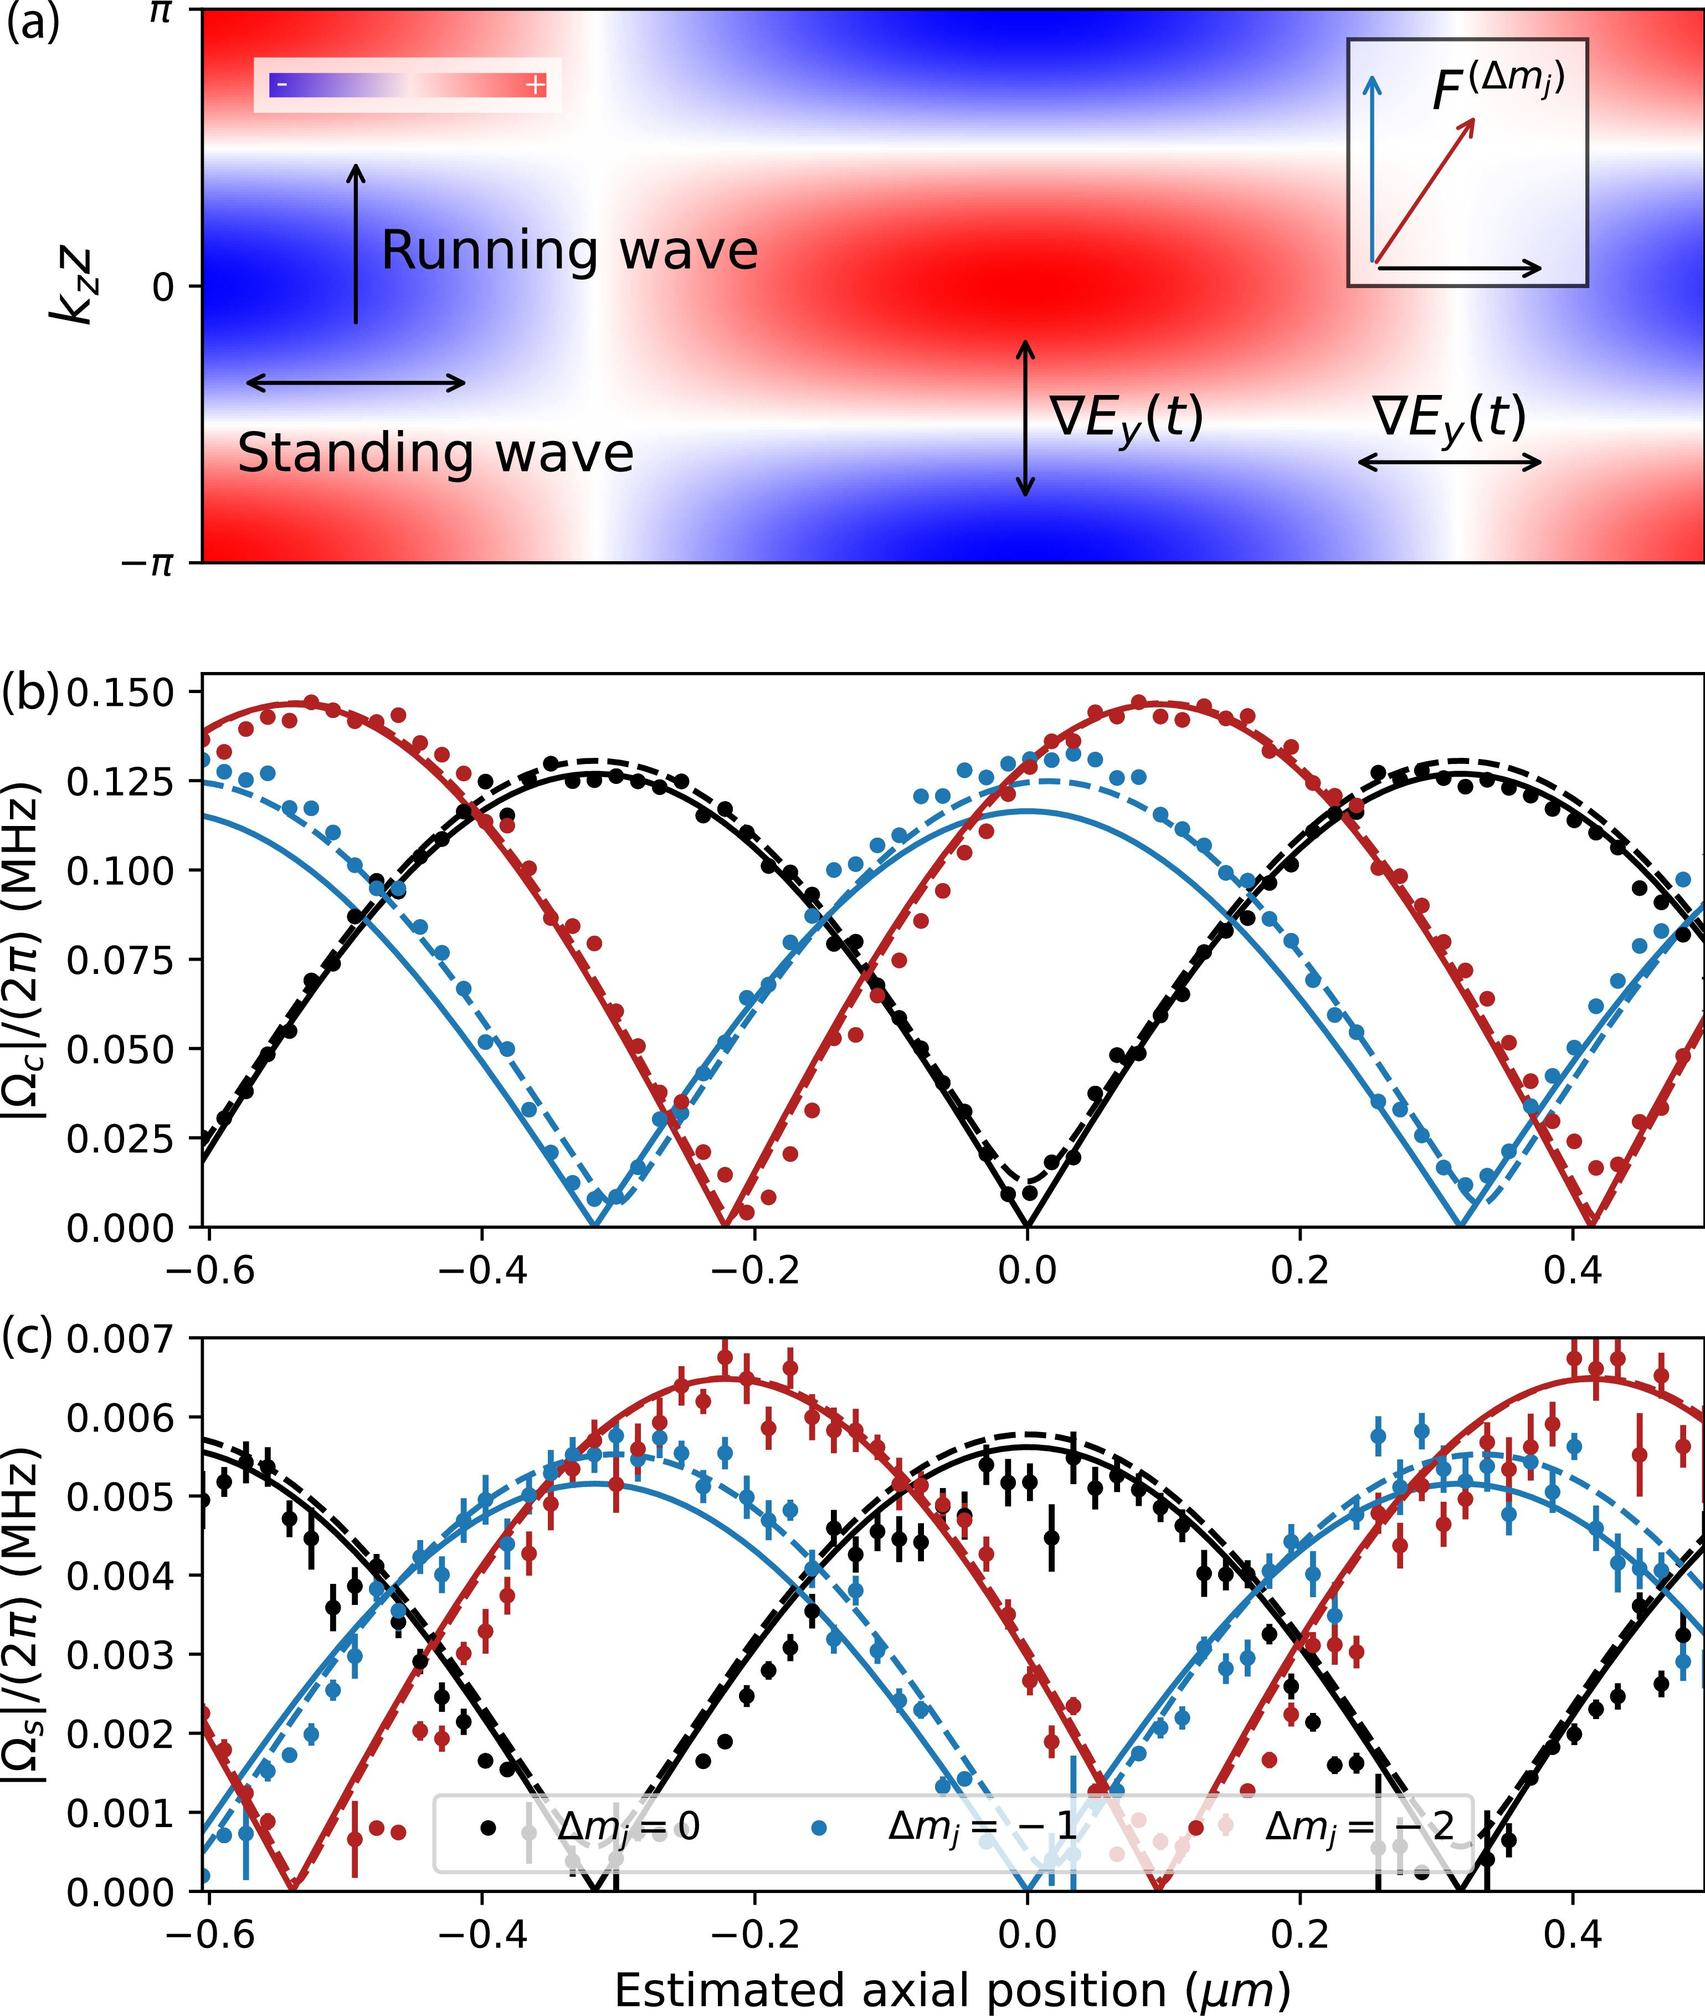Based on Figure (c), which \( \Delta m_j \) value corresponds to the largest variation in \( \Omega_S \) with respect to the estimated axial position? A. \( \Delta m_j = 0 \) B. \( \Delta m_j = -1 \) C. \( \Delta m_j = +2 \) D. \( \Delta m_j = +1 \) In Figure (c), the red curve represents \( \Delta m_j = +2 \) and has the highest peaks and the lowest troughs, indicating the largest variation in \( \Omega_S \) compared to the other \( \Delta m_j \) values plotted. Therefore, the correct answer is C. 